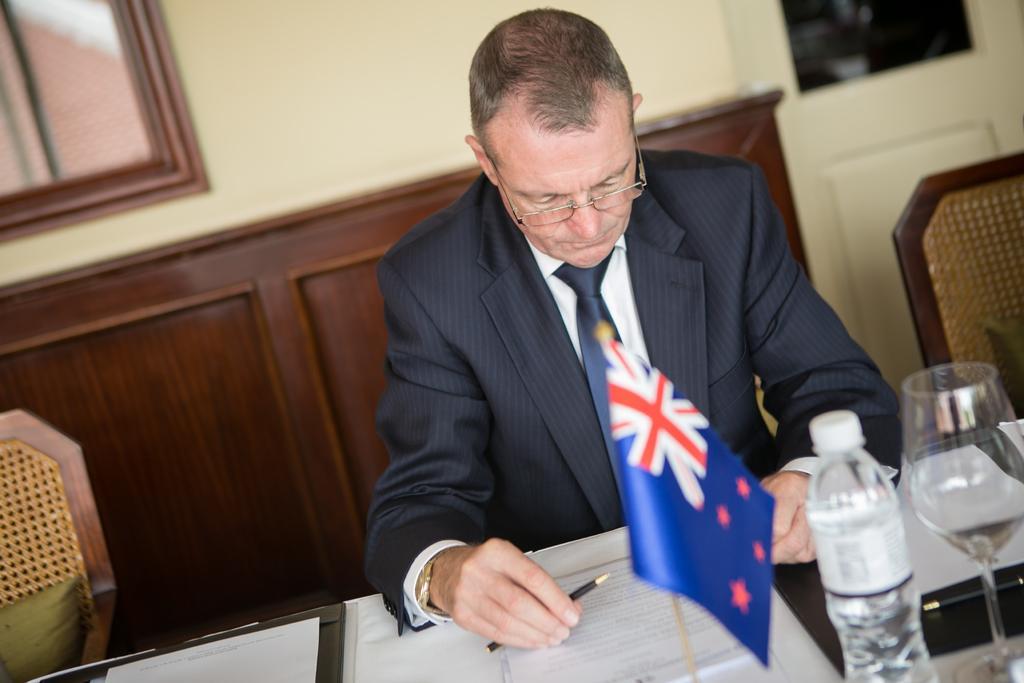Please provide a concise description of this image. In this image there is a person sitting and writing with a pencil in a paper there is bottle, glass , flag in table and in back ground there is wall, cupboard. 